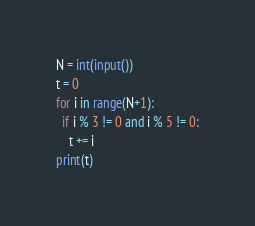Convert code to text. <code><loc_0><loc_0><loc_500><loc_500><_Python_>N = int(input())
t = 0
for i in range(N+1):
  if i % 3 != 0 and i % 5 != 0:
    t += i
print(t)</code> 